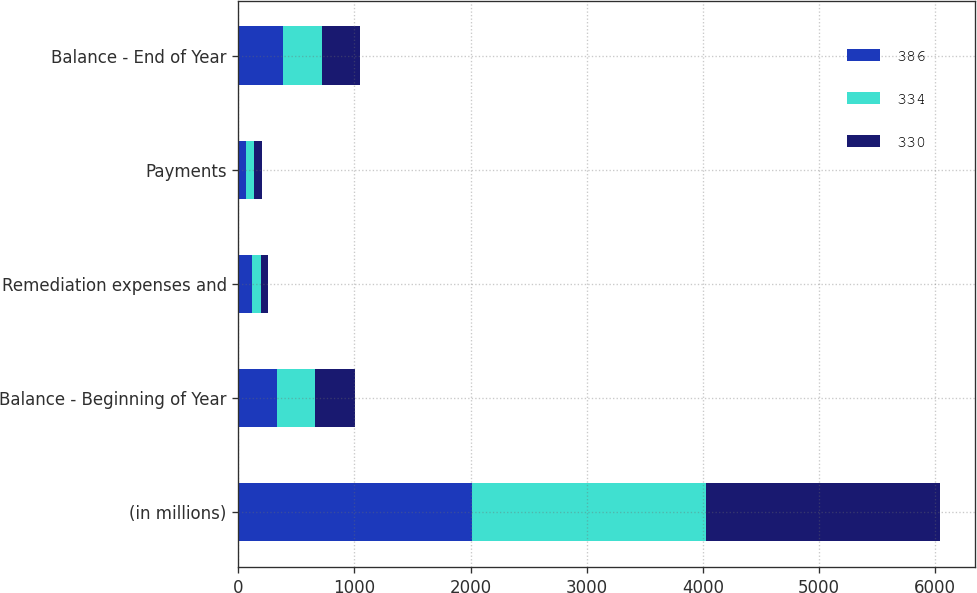<chart> <loc_0><loc_0><loc_500><loc_500><stacked_bar_chart><ecel><fcel>(in millions)<fcel>Balance - Beginning of Year<fcel>Remediation expenses and<fcel>Payments<fcel>Balance - End of Year<nl><fcel>386<fcel>2015<fcel>334<fcel>117<fcel>65<fcel>386<nl><fcel>334<fcel>2014<fcel>330<fcel>79<fcel>68<fcel>334<nl><fcel>330<fcel>2013<fcel>344<fcel>60<fcel>74<fcel>330<nl></chart> 